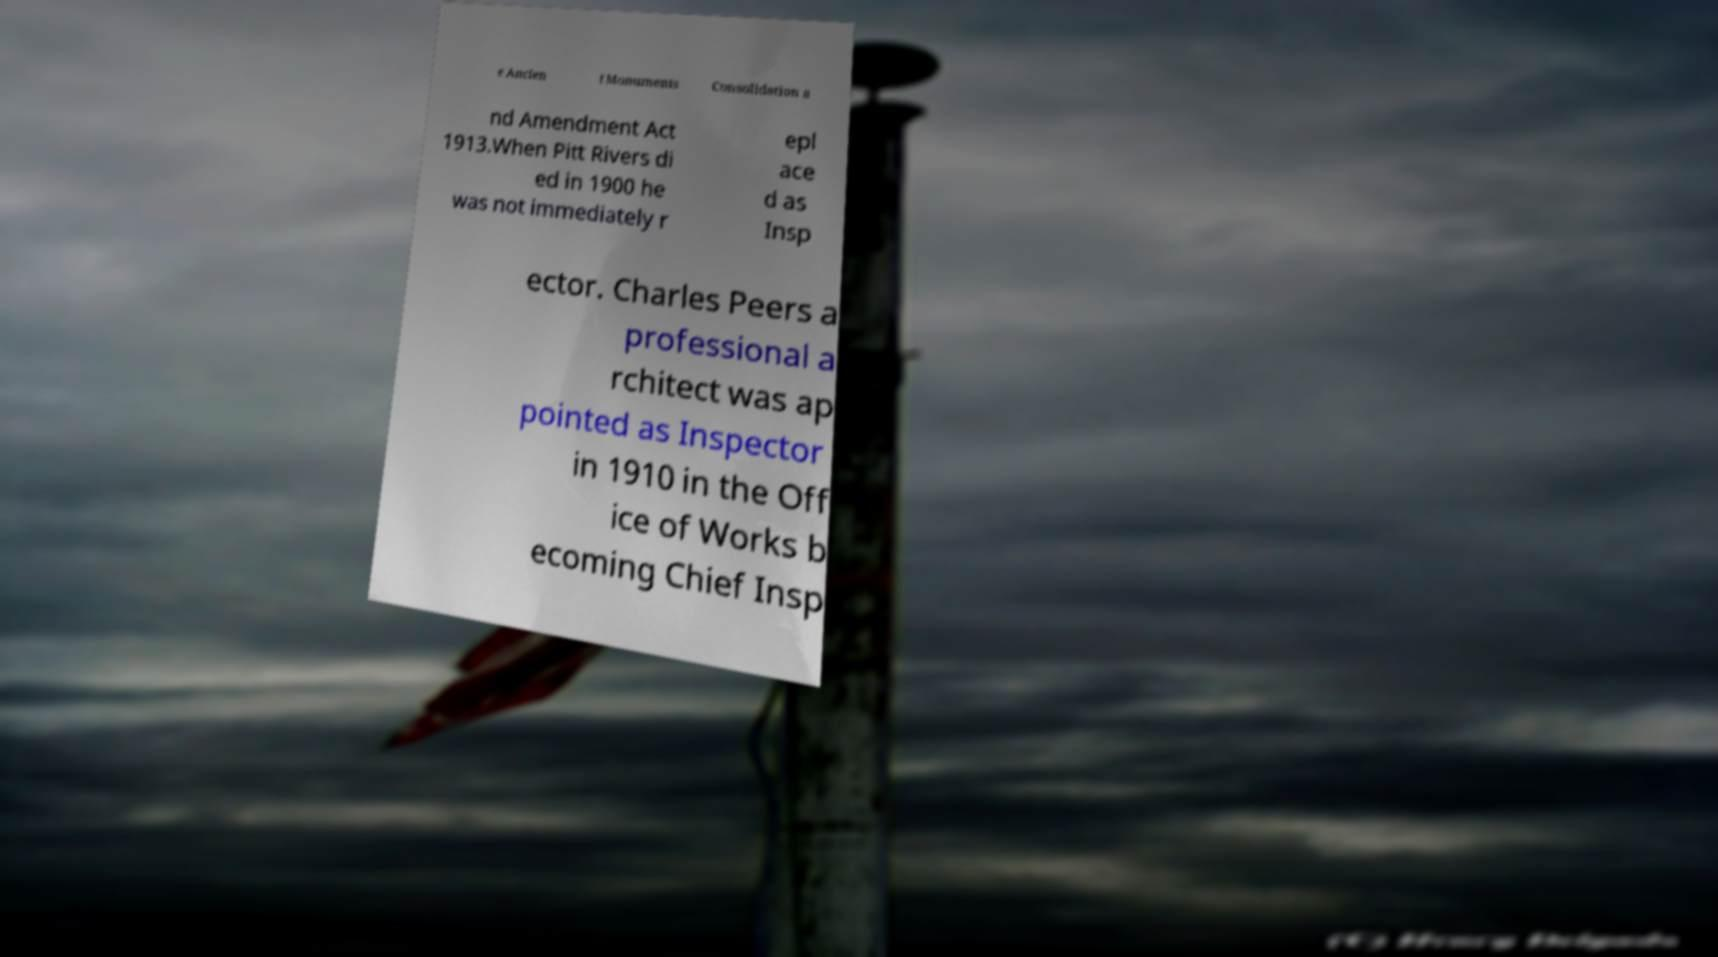Could you extract and type out the text from this image? e Ancien t Monuments Consolidation a nd Amendment Act 1913.When Pitt Rivers di ed in 1900 he was not immediately r epl ace d as Insp ector. Charles Peers a professional a rchitect was ap pointed as Inspector in 1910 in the Off ice of Works b ecoming Chief Insp 